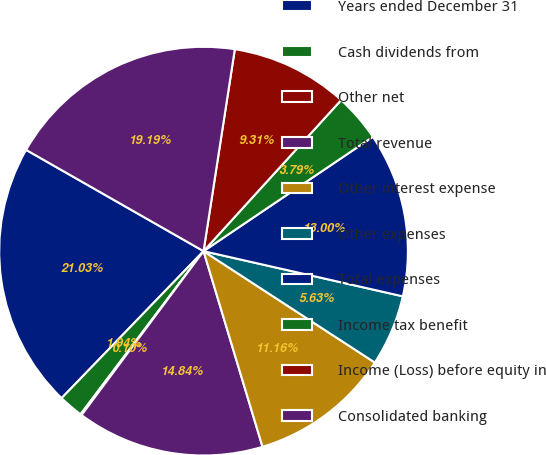Convert chart. <chart><loc_0><loc_0><loc_500><loc_500><pie_chart><fcel>Years ended December 31<fcel>Cash dividends from<fcel>Other net<fcel>Total revenue<fcel>Other interest expense<fcel>Other expenses<fcel>Total expenses<fcel>Income tax benefit<fcel>Income (Loss) before equity in<fcel>Consolidated banking<nl><fcel>21.03%<fcel>1.94%<fcel>0.1%<fcel>14.84%<fcel>11.16%<fcel>5.63%<fcel>13.0%<fcel>3.79%<fcel>9.31%<fcel>19.19%<nl></chart> 